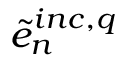Convert formula to latex. <formula><loc_0><loc_0><loc_500><loc_500>\tilde { e } _ { n } ^ { i n c , q }</formula> 